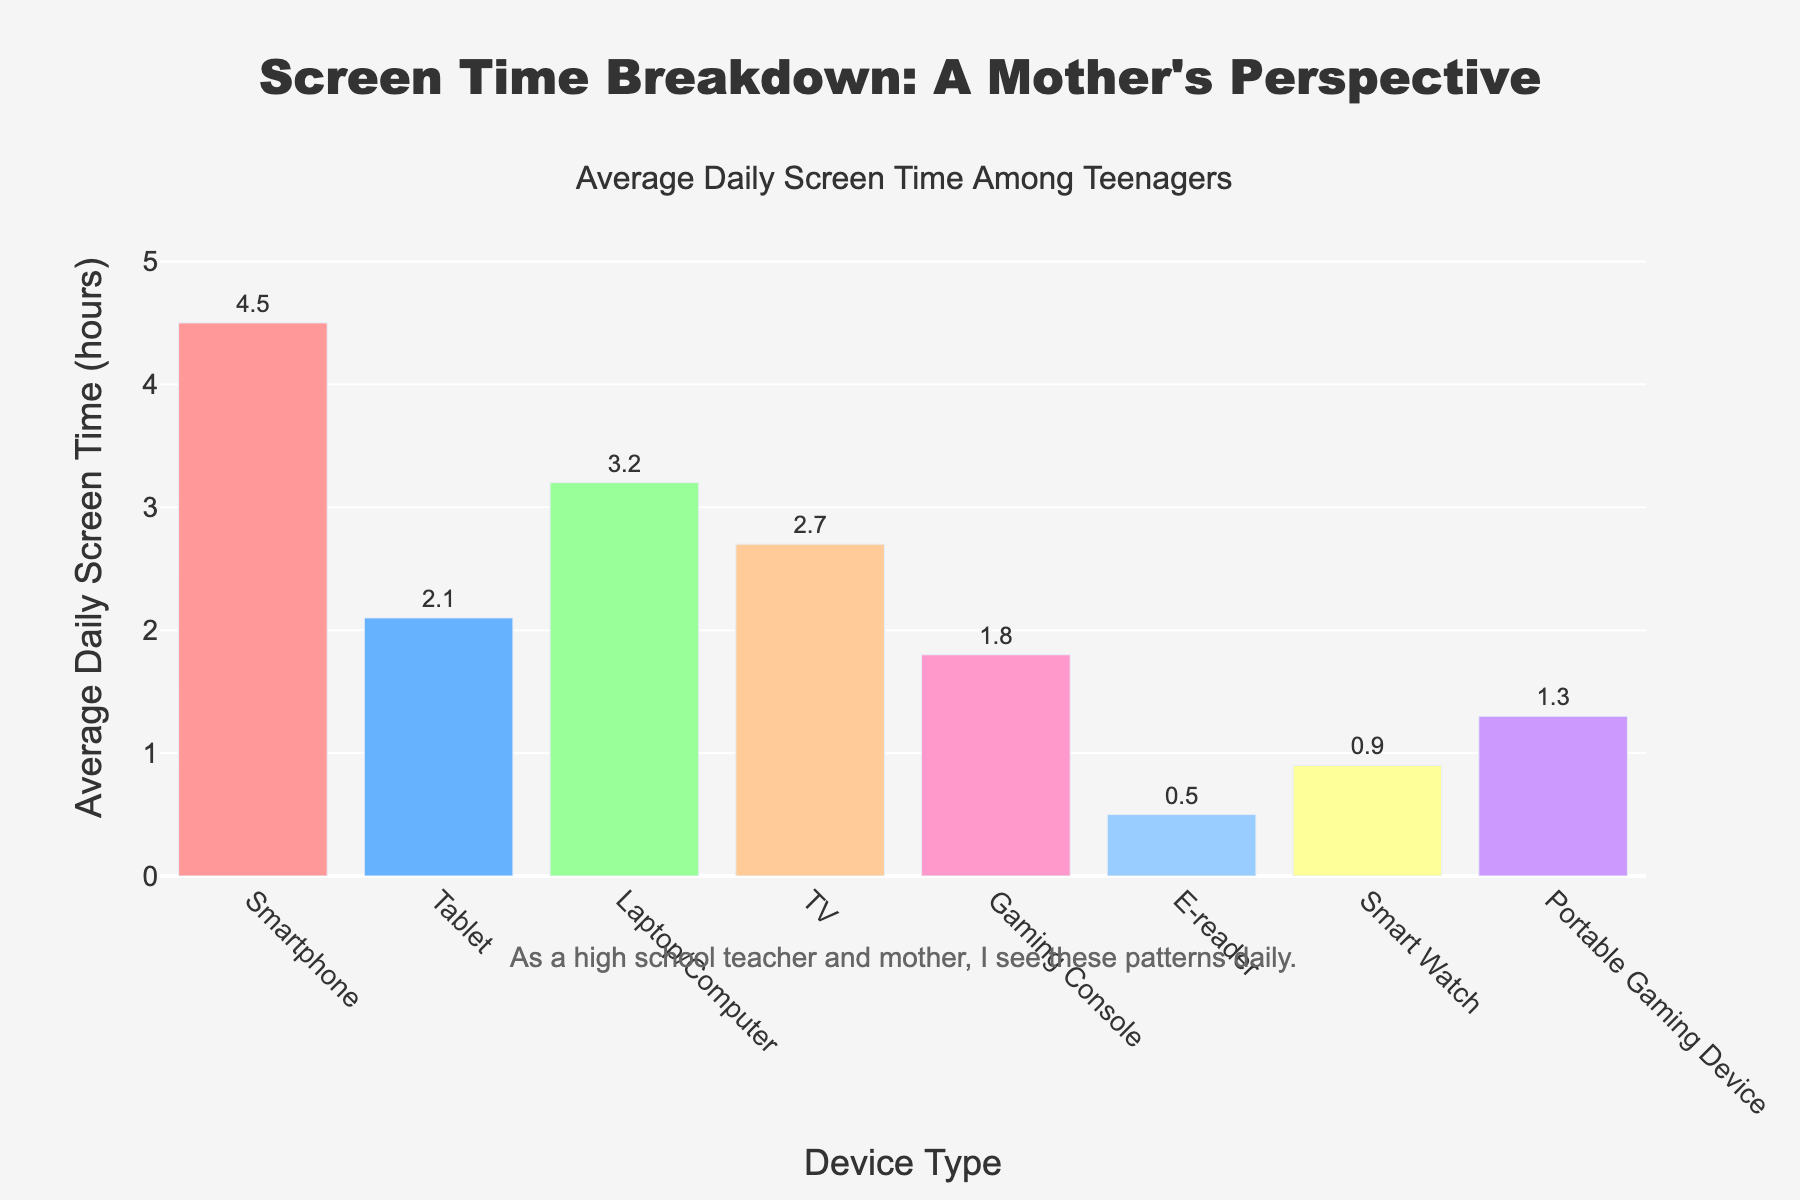Which device type has the highest average daily screen time? The height of the bars represents average daily screen time. The tallest bar corresponds to the Smartphone device type.
Answer: Smartphone Which device type has the lowest screen time? The shortest bar represents the device type with the lowest screen time, which is the E-reader.
Answer: E-reader What's the difference in average daily screen time between Smartphones and Tablets? The average daily screen time for Smartphones is 4.5 hours, and for Tablets, it is 2.1 hours. The difference is 4.5 - 2.1 = 2.4 hours.
Answer: 2.4 hours How much more screen time is spent on Laptops/Computers compared to Gaming Consoles? The average daily screen time for Laptops/Computers is 3.2 hours, and for Gaming Consoles, it is 1.8 hours. The difference is 3.2 - 1.8 = 1.4 hours.
Answer: 1.4 hours What is the sum of the average daily screen time for Smart Watches and Portable Gaming Devices? The average daily screen time for Smart Watches is 0.9 hours, and for Portable Gaming Devices, it is 1.3 hours. The sum is 0.9 + 1.3 = 2.2 hours.
Answer: 2.2 hours Which two device types have the closest average daily screen time? The bar for Tablet (2.1) and TV (2.7) show values closest to each other. Considering the difference, 2.7 - 2.1 = 0.6 is the smallest difference among all pairs.
Answer: Tablet and TV Compare the average daily screen time usage between Smartphones and e-Readers. By how many factors is the Smartphone usage greater? The average daily screen time for Smartphones is 4.5 hours and for E-readers is 0.5 hours. The factor is calculated as 4.5 / 0.5 = 9.
Answer: 9 times Order the device types by average daily screen time from highest to lowest. By observing the height of the bars, we can list: Smartphone, Laptop/Computer, TV, Tablet, Gaming Console, Portable Gaming Device, Smart Watch, E-Reader.
Answer: Smartphone, Laptop/Computer, TV, Tablet, Gaming Console, Portable Gaming Device, Smart Watch, E-Reader What is the total average screen time combined for all device types? Adding the screen time for all devices: 4.5 + 2.1 + 3.2 + 2.7 + 1.8 + 0.5 + 0.9 + 1.3 = 17 hours.
Answer: 17 hours 